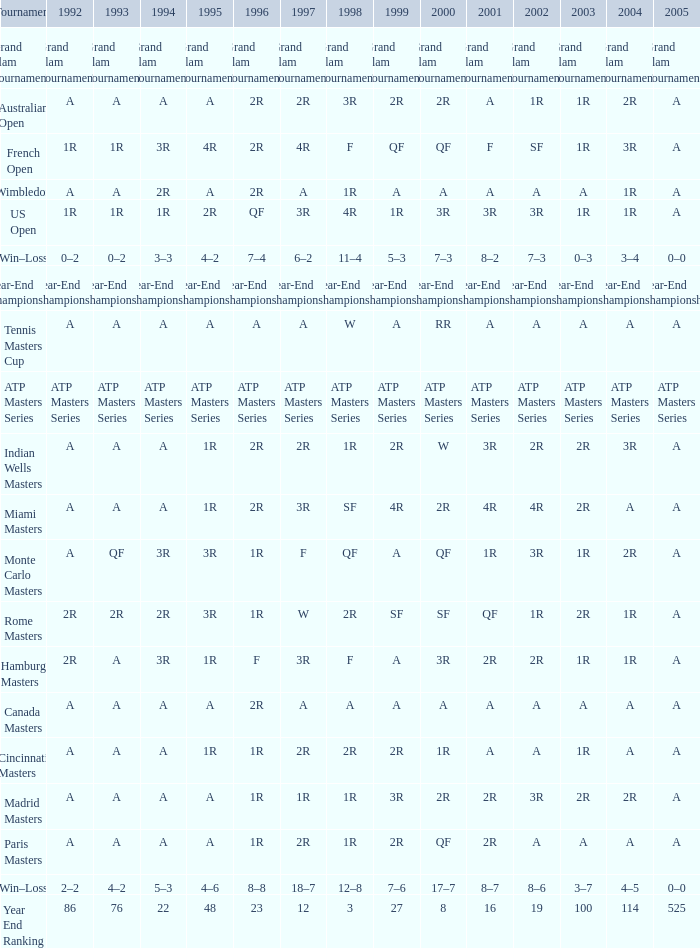What is the contest, when 2000 is "a"? Wimbledon, Canada Masters. 